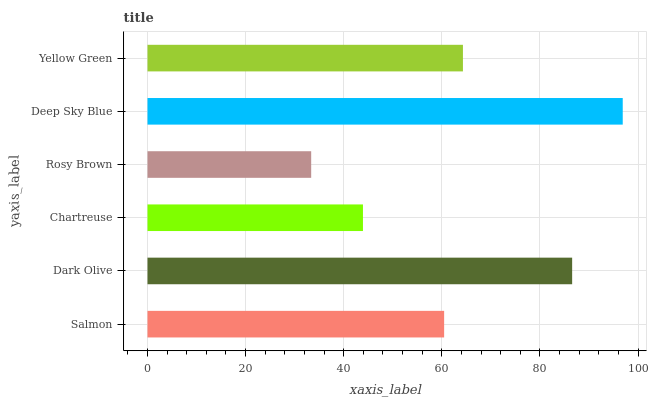Is Rosy Brown the minimum?
Answer yes or no. Yes. Is Deep Sky Blue the maximum?
Answer yes or no. Yes. Is Dark Olive the minimum?
Answer yes or no. No. Is Dark Olive the maximum?
Answer yes or no. No. Is Dark Olive greater than Salmon?
Answer yes or no. Yes. Is Salmon less than Dark Olive?
Answer yes or no. Yes. Is Salmon greater than Dark Olive?
Answer yes or no. No. Is Dark Olive less than Salmon?
Answer yes or no. No. Is Yellow Green the high median?
Answer yes or no. Yes. Is Salmon the low median?
Answer yes or no. Yes. Is Salmon the high median?
Answer yes or no. No. Is Rosy Brown the low median?
Answer yes or no. No. 